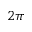Convert formula to latex. <formula><loc_0><loc_0><loc_500><loc_500>2 \pi</formula> 